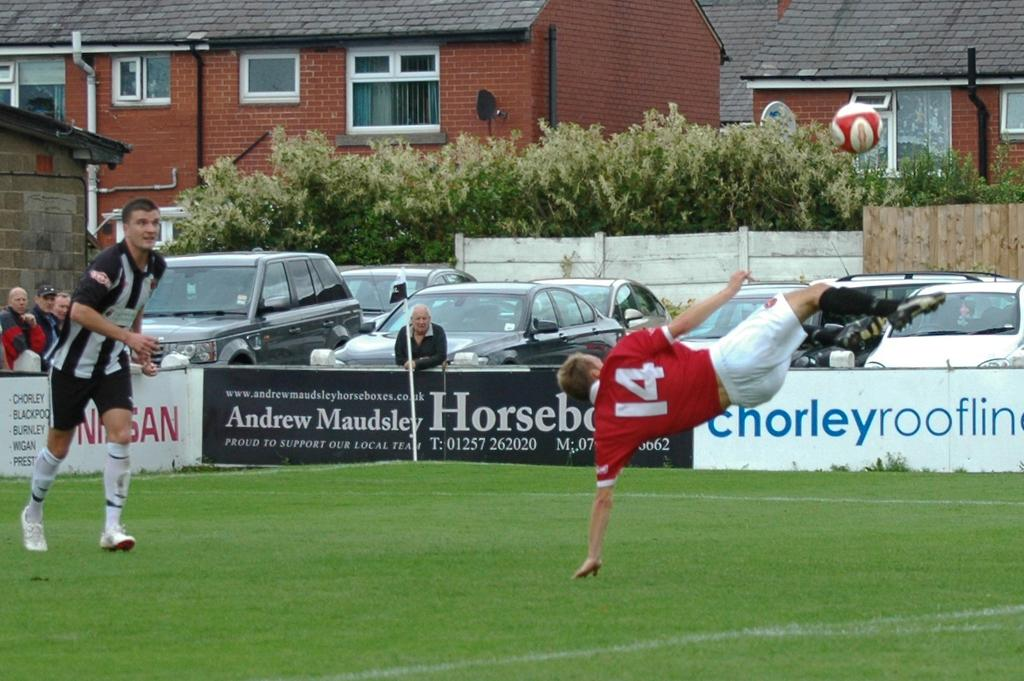<image>
Write a terse but informative summary of the picture. the man wearing number 14 red jersey is kicking the ball 